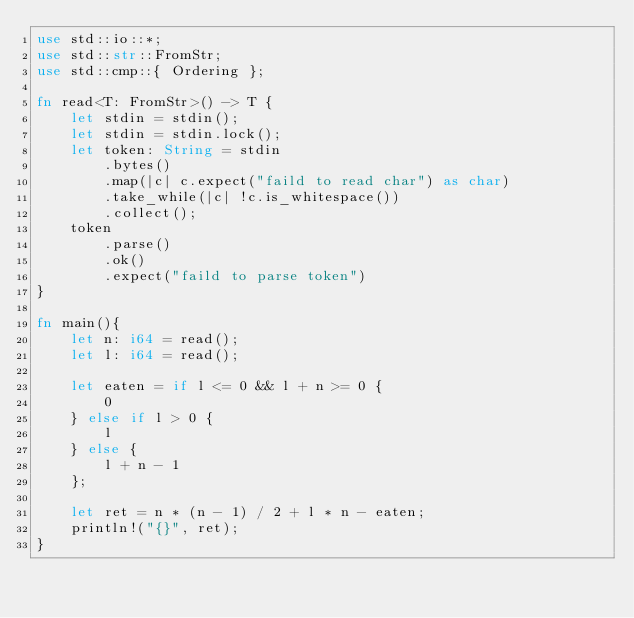<code> <loc_0><loc_0><loc_500><loc_500><_Rust_>use std::io::*;
use std::str::FromStr;
use std::cmp::{ Ordering };

fn read<T: FromStr>() -> T {
    let stdin = stdin();
    let stdin = stdin.lock();
    let token: String = stdin
        .bytes()
        .map(|c| c.expect("faild to read char") as char)
        .take_while(|c| !c.is_whitespace())
        .collect();
    token
        .parse()
        .ok()
        .expect("faild to parse token")
}

fn main(){
    let n: i64 = read();
    let l: i64 = read();

    let eaten = if l <= 0 && l + n >= 0 {
        0
    } else if l > 0 {
        l
    } else {
        l + n - 1
    };

    let ret = n * (n - 1) / 2 + l * n - eaten;
    println!("{}", ret);
}
</code> 